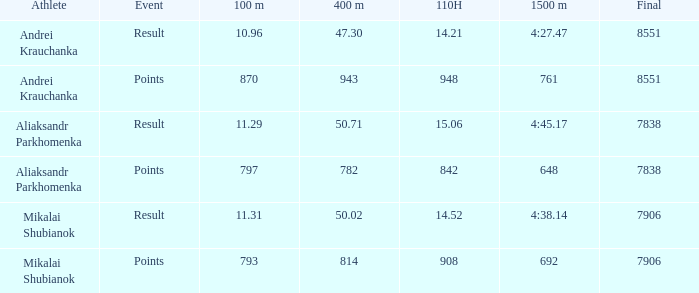In which 400m races was there a 110h measurement over 14.21, a final sum over 7838, and documented event results? 1.0. 